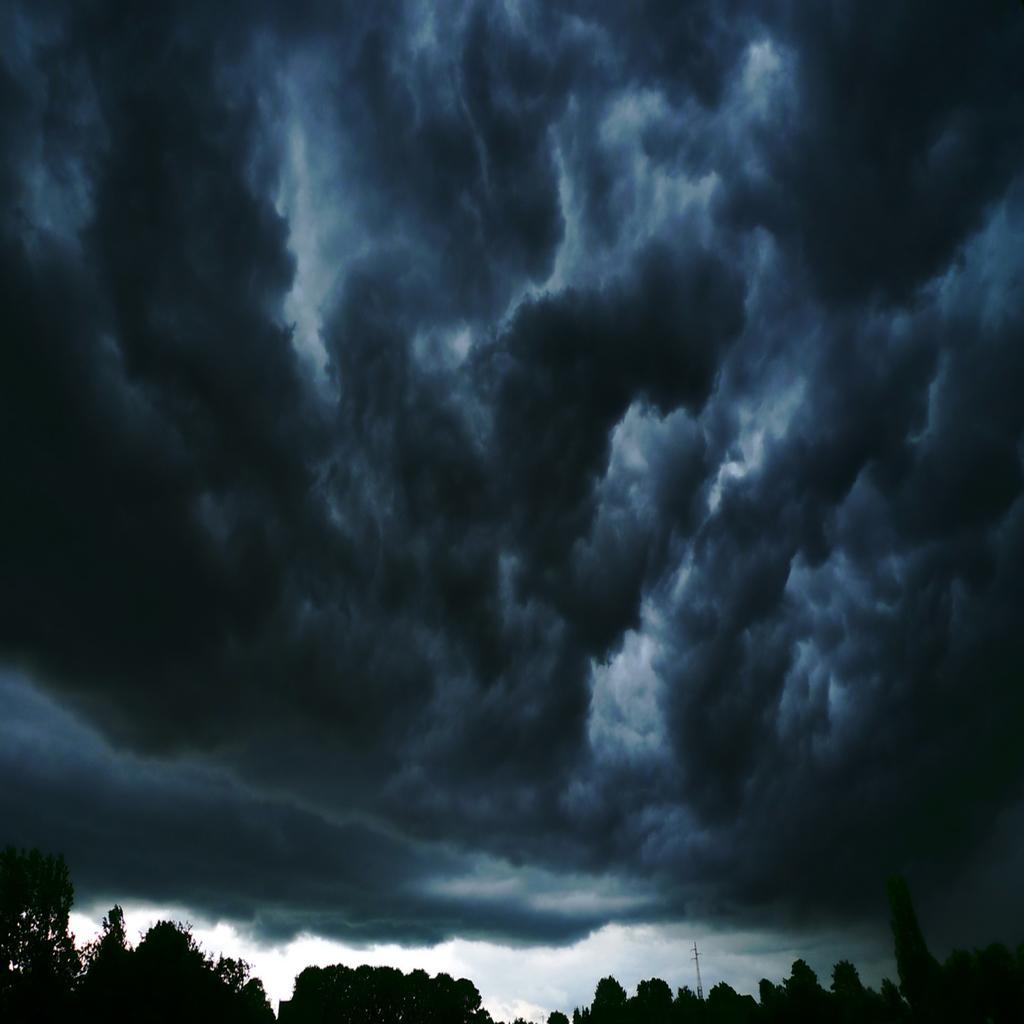Can you describe this image briefly? In this picture I can see some trees and cloudy sky. 